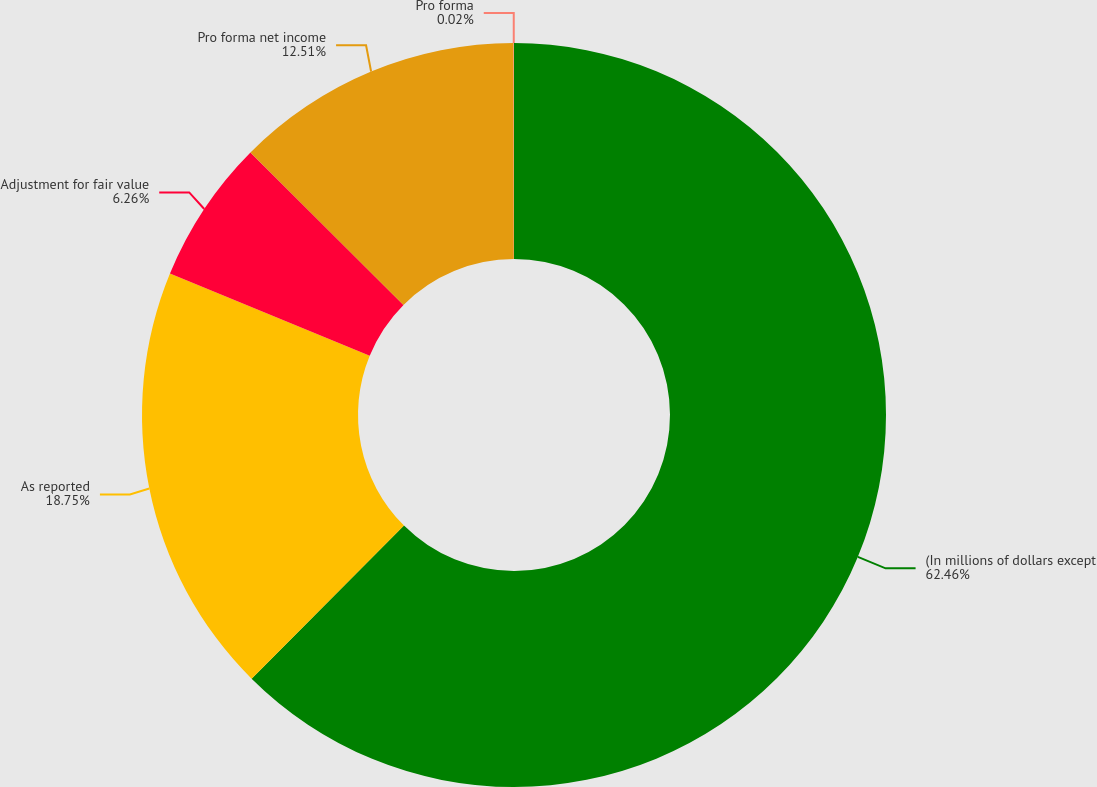<chart> <loc_0><loc_0><loc_500><loc_500><pie_chart><fcel>(In millions of dollars except<fcel>As reported<fcel>Adjustment for fair value<fcel>Pro forma net income<fcel>Pro forma<nl><fcel>62.46%<fcel>18.75%<fcel>6.26%<fcel>12.51%<fcel>0.02%<nl></chart> 